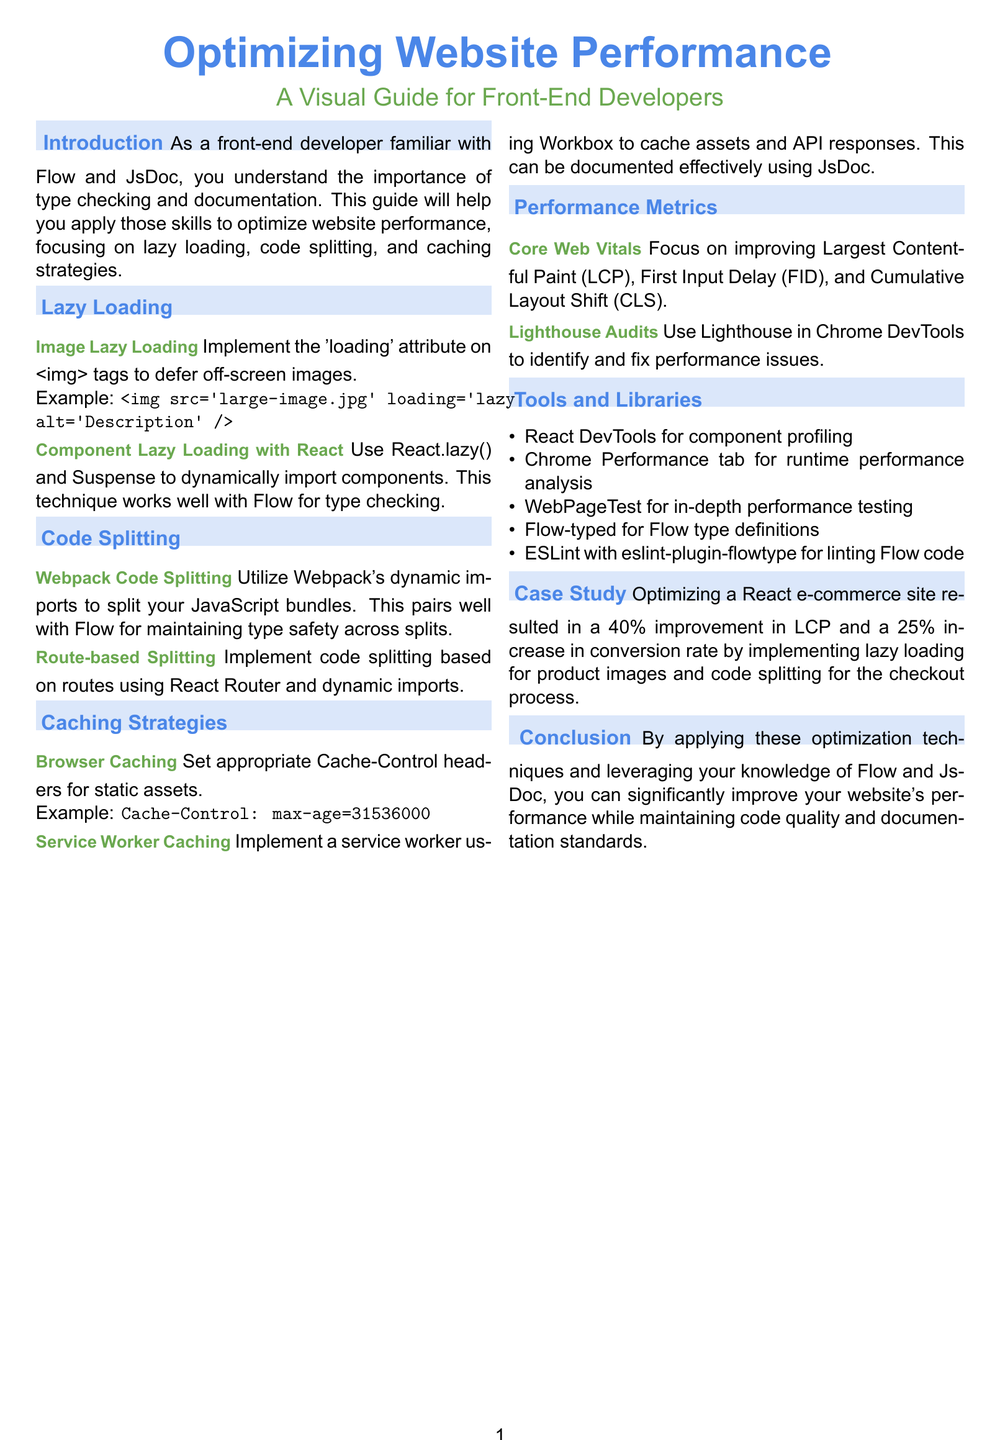what is the main focus of the guide? The guide focuses on optimizing website performance for front-end developers, specifically through lazy loading, code splitting, and caching strategies.
Answer: optimizing website performance what attribute should be implemented for image lazy loading? The document specifies the implementation of the 'loading' attribute on image tags to defer off-screen images.
Answer: loading which library is suggested for implementing service worker caching? The document recommends using Workbox for implementing a service worker to cache assets and API responses.
Answer: Workbox what is the percentage improvement in Largest Contentful Paint for the e-commerce site case study? The case study indicates a 40% improvement in Largest Contentful Paint (LCP) for the optimized site.
Answer: 40% name one tool mentioned for runtime performance analysis. The document lists the Chrome Performance tab as a tool for runtime performance analysis.
Answer: Chrome Performance tab which component can be lazy-loaded in React using a specific method? The document mentions using React.lazy() and Suspense to dynamically import components in React.
Answer: React.lazy() what are the three Core Web Vitals to focus on? The guide outlines that the focus should be on Largest Contentful Paint, First Input Delay, and Cumulative Layout Shift.
Answer: Largest Contentful Paint, First Input Delay, Cumulative Layout Shift how much was the increase in conversion rate from the case study? The case study states that there was a 25% increase in conversion rate after implementing performance optimizations.
Answer: 25% 